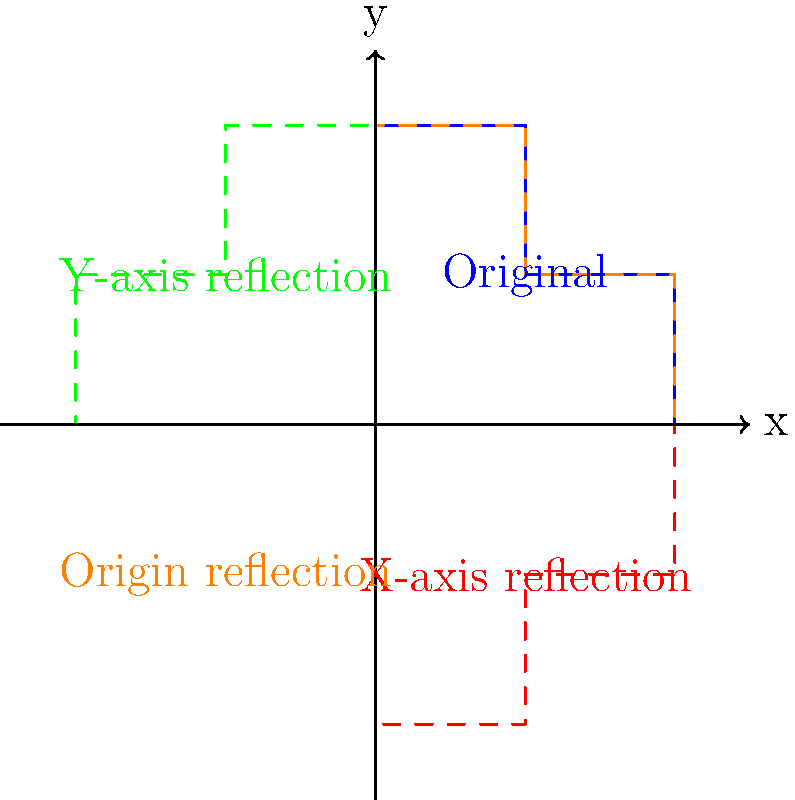Consider the cross-section of a firearm barrel represented by the blue shape in the diagram. If this shape is reflected across various axes, which reflection preserves the original orientation of the cross-section? To solve this problem, we need to analyze each reflection and compare it to the original shape:

1. X-axis reflection (red dashed line):
   This flips the shape vertically, changing its orientation.

2. Y-axis reflection (green dashed line):
   This flips the shape horizontally, changing its orientation.

3. Origin reflection (orange dashed line):
   This rotates the shape 180 degrees, preserving its orientation.

The key concept here is that a reflection across a line changes the orientation of a shape, while a 180-degree rotation (which is equivalent to a reflection through a point) preserves the orientation.

In this case, the reflection through the origin (orange dashed line) is equivalent to a 180-degree rotation around the origin. This transformation preserves the orientation of the original shape, making it the only reflection that maintains the original orientation of the cross-section.

This principle is important in firearm design and manufacturing, as it relates to the symmetry and balance of the barrel, which can affect accuracy and performance.
Answer: Reflection through the origin 